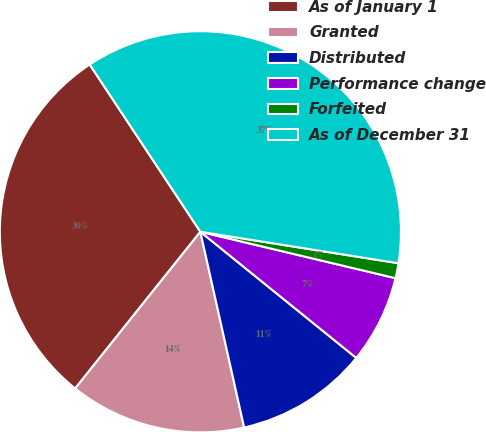Convert chart. <chart><loc_0><loc_0><loc_500><loc_500><pie_chart><fcel>As of January 1<fcel>Granted<fcel>Distributed<fcel>Performance change<fcel>Forfeited<fcel>As of December 31<nl><fcel>29.97%<fcel>14.23%<fcel>10.67%<fcel>7.11%<fcel>1.21%<fcel>36.81%<nl></chart> 